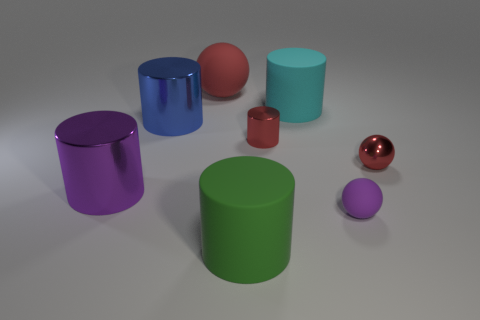Is the size of the blue shiny cylinder the same as the red sphere that is to the right of the large sphere?
Your response must be concise. No. Do the green thing and the metal ball have the same size?
Ensure brevity in your answer.  No. There is a rubber ball that is in front of the red sphere that is right of the sphere that is to the left of the cyan rubber cylinder; how big is it?
Make the answer very short. Small. What material is the tiny sphere that is in front of the shiny cylinder left of the blue metal thing?
Provide a succinct answer. Rubber. Are there any cyan metal things of the same shape as the large blue object?
Provide a succinct answer. No. The tiny purple rubber object has what shape?
Your response must be concise. Sphere. What material is the purple object to the left of the red sphere behind the tiny cylinder on the right side of the blue metallic object made of?
Provide a short and direct response. Metal. Is the number of big matte things that are behind the red shiny ball greater than the number of blue spheres?
Offer a terse response. Yes. What material is the cylinder that is the same size as the purple matte sphere?
Keep it short and to the point. Metal. Are there any purple metallic things of the same size as the green cylinder?
Your response must be concise. Yes. 